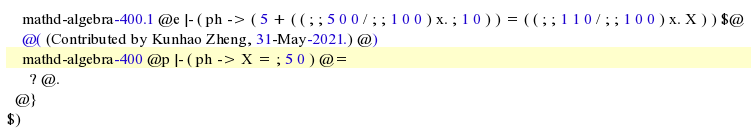Convert code to text. <code><loc_0><loc_0><loc_500><loc_500><_ObjectiveC_>    mathd-algebra-400.1 @e |- ( ph -> ( 5 + ( ( ; ; 5 0 0 / ; ; 1 0 0 ) x. ; 1 0 ) ) = ( ( ; ; 1 1 0 / ; ; 1 0 0 ) x. X ) ) $@
    @( (Contributed by Kunhao Zheng, 31-May-2021.) @)
    mathd-algebra-400 @p |- ( ph -> X = ; 5 0 ) @=
      ? @.
  @}
$)
</code> 